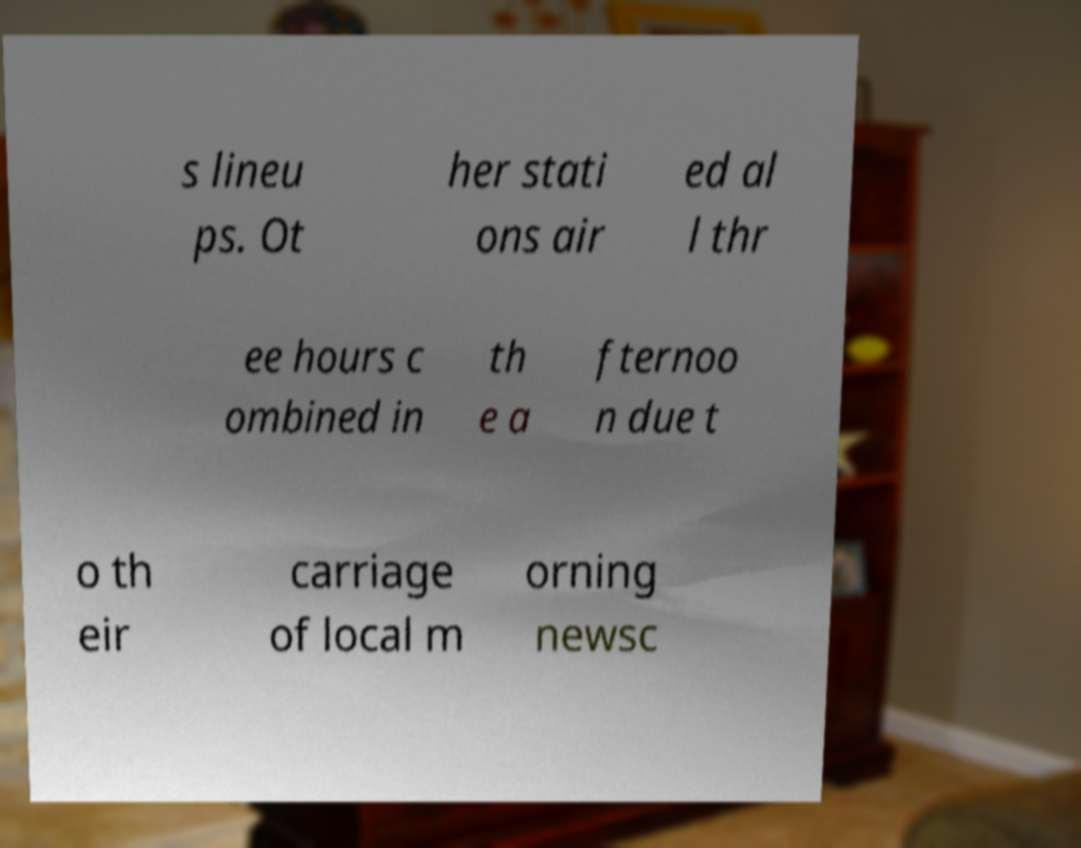For documentation purposes, I need the text within this image transcribed. Could you provide that? s lineu ps. Ot her stati ons air ed al l thr ee hours c ombined in th e a fternoo n due t o th eir carriage of local m orning newsc 